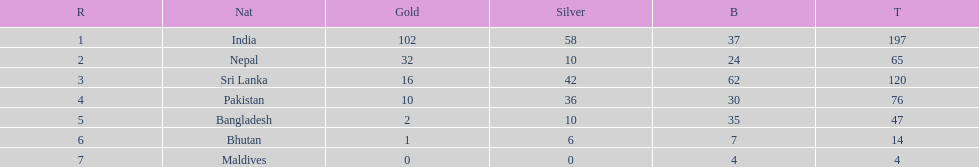What is the difference between the nation with the most medals and the nation with the least amount of medals? 193. 